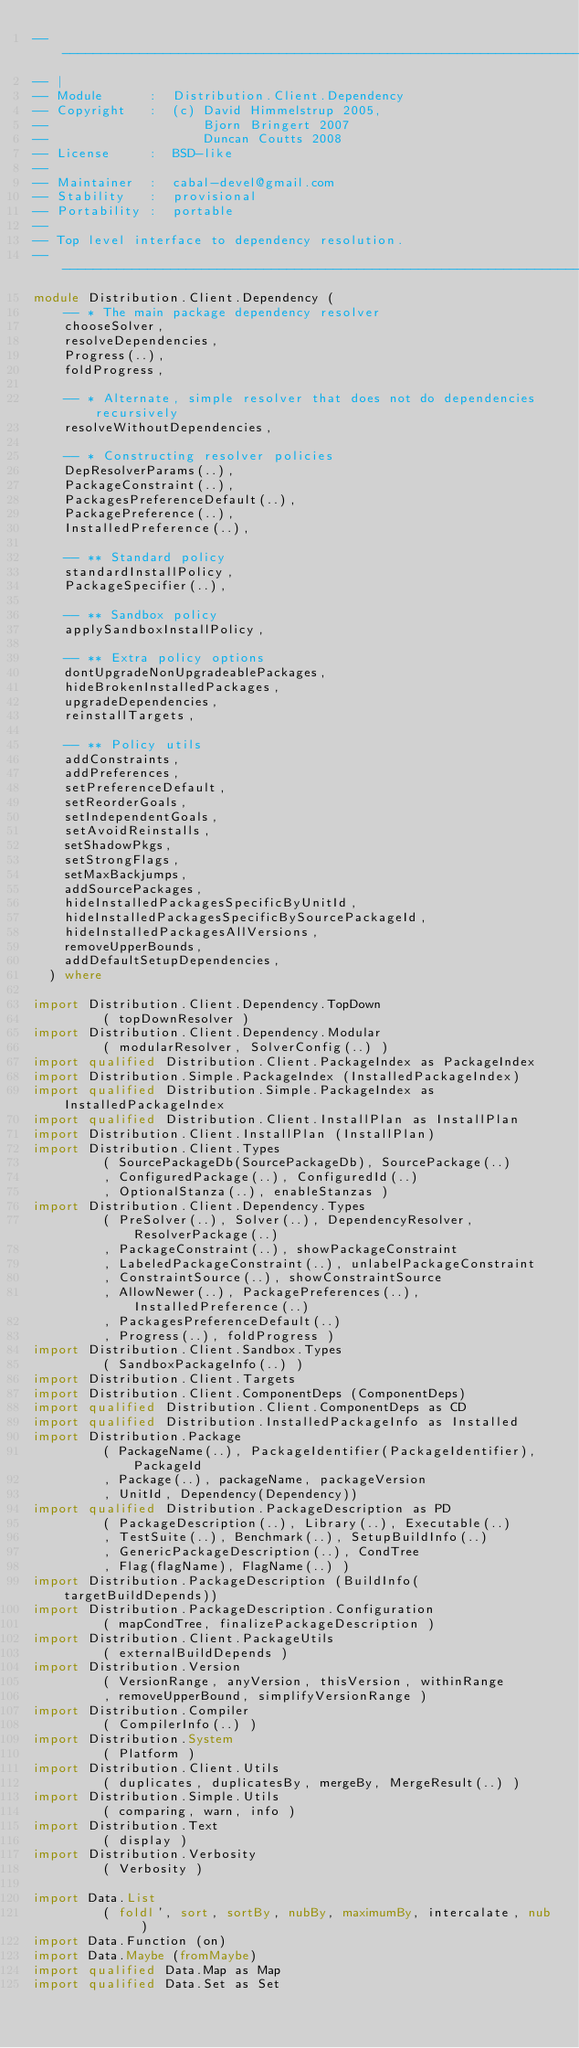<code> <loc_0><loc_0><loc_500><loc_500><_Haskell_>-----------------------------------------------------------------------------
-- |
-- Module      :  Distribution.Client.Dependency
-- Copyright   :  (c) David Himmelstrup 2005,
--                    Bjorn Bringert 2007
--                    Duncan Coutts 2008
-- License     :  BSD-like
--
-- Maintainer  :  cabal-devel@gmail.com
-- Stability   :  provisional
-- Portability :  portable
--
-- Top level interface to dependency resolution.
-----------------------------------------------------------------------------
module Distribution.Client.Dependency (
    -- * The main package dependency resolver
    chooseSolver,
    resolveDependencies,
    Progress(..),
    foldProgress,

    -- * Alternate, simple resolver that does not do dependencies recursively
    resolveWithoutDependencies,

    -- * Constructing resolver policies
    DepResolverParams(..),
    PackageConstraint(..),
    PackagesPreferenceDefault(..),
    PackagePreference(..),
    InstalledPreference(..),

    -- ** Standard policy
    standardInstallPolicy,
    PackageSpecifier(..),

    -- ** Sandbox policy
    applySandboxInstallPolicy,

    -- ** Extra policy options
    dontUpgradeNonUpgradeablePackages,
    hideBrokenInstalledPackages,
    upgradeDependencies,
    reinstallTargets,

    -- ** Policy utils
    addConstraints,
    addPreferences,
    setPreferenceDefault,
    setReorderGoals,
    setIndependentGoals,
    setAvoidReinstalls,
    setShadowPkgs,
    setStrongFlags,
    setMaxBackjumps,
    addSourcePackages,
    hideInstalledPackagesSpecificByUnitId,
    hideInstalledPackagesSpecificBySourcePackageId,
    hideInstalledPackagesAllVersions,
    removeUpperBounds,
    addDefaultSetupDependencies,
  ) where

import Distribution.Client.Dependency.TopDown
         ( topDownResolver )
import Distribution.Client.Dependency.Modular
         ( modularResolver, SolverConfig(..) )
import qualified Distribution.Client.PackageIndex as PackageIndex
import Distribution.Simple.PackageIndex (InstalledPackageIndex)
import qualified Distribution.Simple.PackageIndex as InstalledPackageIndex
import qualified Distribution.Client.InstallPlan as InstallPlan
import Distribution.Client.InstallPlan (InstallPlan)
import Distribution.Client.Types
         ( SourcePackageDb(SourcePackageDb), SourcePackage(..)
         , ConfiguredPackage(..), ConfiguredId(..)
         , OptionalStanza(..), enableStanzas )
import Distribution.Client.Dependency.Types
         ( PreSolver(..), Solver(..), DependencyResolver, ResolverPackage(..)
         , PackageConstraint(..), showPackageConstraint
         , LabeledPackageConstraint(..), unlabelPackageConstraint
         , ConstraintSource(..), showConstraintSource
         , AllowNewer(..), PackagePreferences(..), InstalledPreference(..)
         , PackagesPreferenceDefault(..)
         , Progress(..), foldProgress )
import Distribution.Client.Sandbox.Types
         ( SandboxPackageInfo(..) )
import Distribution.Client.Targets
import Distribution.Client.ComponentDeps (ComponentDeps)
import qualified Distribution.Client.ComponentDeps as CD
import qualified Distribution.InstalledPackageInfo as Installed
import Distribution.Package
         ( PackageName(..), PackageIdentifier(PackageIdentifier), PackageId
         , Package(..), packageName, packageVersion
         , UnitId, Dependency(Dependency))
import qualified Distribution.PackageDescription as PD
         ( PackageDescription(..), Library(..), Executable(..)
         , TestSuite(..), Benchmark(..), SetupBuildInfo(..)
         , GenericPackageDescription(..), CondTree
         , Flag(flagName), FlagName(..) )
import Distribution.PackageDescription (BuildInfo(targetBuildDepends))
import Distribution.PackageDescription.Configuration
         ( mapCondTree, finalizePackageDescription )
import Distribution.Client.PackageUtils
         ( externalBuildDepends )
import Distribution.Version
         ( VersionRange, anyVersion, thisVersion, withinRange
         , removeUpperBound, simplifyVersionRange )
import Distribution.Compiler
         ( CompilerInfo(..) )
import Distribution.System
         ( Platform )
import Distribution.Client.Utils
         ( duplicates, duplicatesBy, mergeBy, MergeResult(..) )
import Distribution.Simple.Utils
         ( comparing, warn, info )
import Distribution.Text
         ( display )
import Distribution.Verbosity
         ( Verbosity )

import Data.List
         ( foldl', sort, sortBy, nubBy, maximumBy, intercalate, nub )
import Data.Function (on)
import Data.Maybe (fromMaybe)
import qualified Data.Map as Map
import qualified Data.Set as Set</code> 